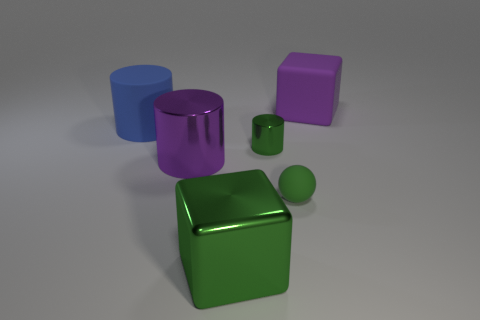How many objects are there, and can you describe their shapes? There are five objects in the image. Starting from the left, there is a blue cylinder, a green cube, a purple cube, a small green sphere, and a small purple cylinder. 